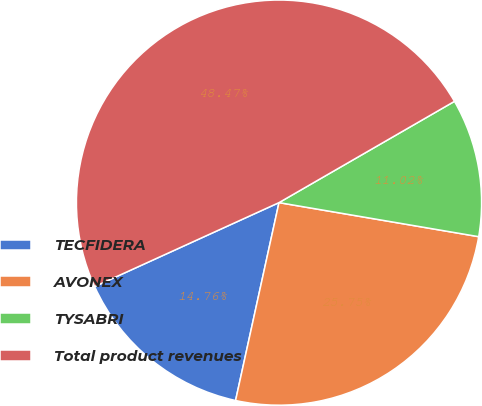<chart> <loc_0><loc_0><loc_500><loc_500><pie_chart><fcel>TECFIDERA<fcel>AVONEX<fcel>TYSABRI<fcel>Total product revenues<nl><fcel>14.76%<fcel>25.75%<fcel>11.02%<fcel>48.47%<nl></chart> 